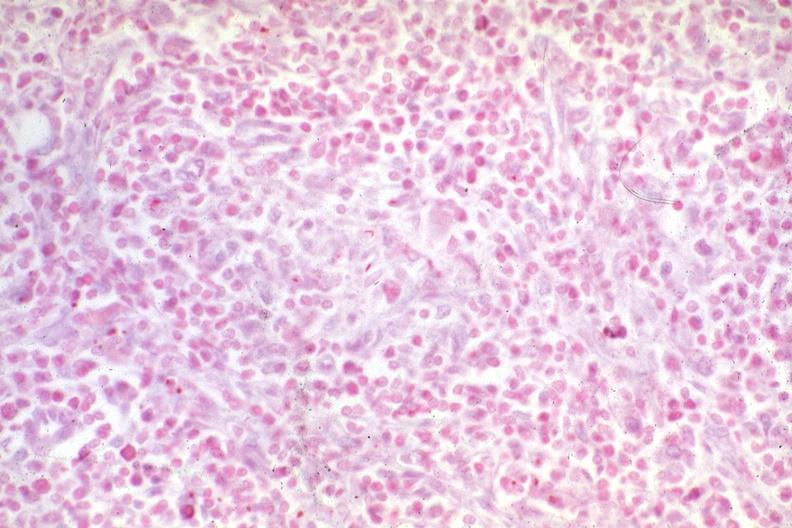what does this image show?
Answer the question using a single word or phrase. Acid fast hemophiliac with aids typical 